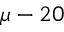Convert formula to latex. <formula><loc_0><loc_0><loc_500><loc_500>\mu - 2 0</formula> 